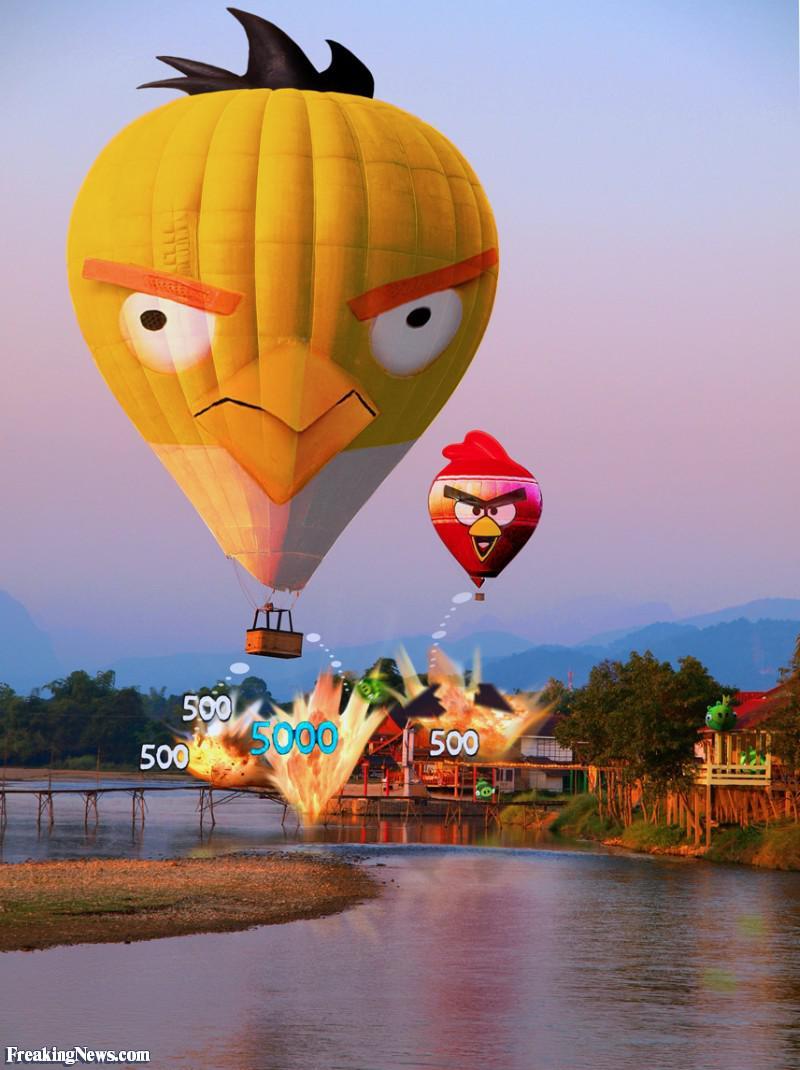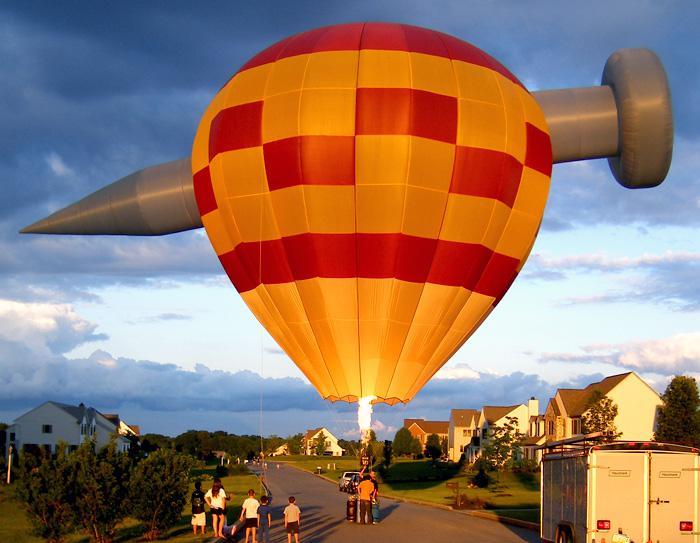The first image is the image on the left, the second image is the image on the right. Analyze the images presented: Is the assertion "There are no more than two hot air balloons." valid? Answer yes or no. No. The first image is the image on the left, the second image is the image on the right. Evaluate the accuracy of this statement regarding the images: "One of the images has at least one hot air balloon with characters or pictures on it.". Is it true? Answer yes or no. Yes. 